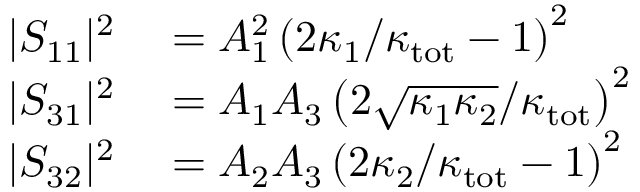Convert formula to latex. <formula><loc_0><loc_0><loc_500><loc_500>\begin{array} { r l } { | S _ { 1 1 } | ^ { 2 } } & = A _ { 1 } ^ { 2 } \left ( 2 \kappa _ { 1 } / \kappa _ { t o t } - 1 \right ) ^ { 2 } } \\ { | S _ { 3 1 } | ^ { 2 } } & = A _ { 1 } A _ { 3 } \left ( 2 \sqrt { \kappa _ { 1 } \kappa _ { 2 } } / \kappa _ { t o t } \right ) ^ { 2 } } \\ { | S _ { 3 2 } | ^ { 2 } } & = A _ { 2 } A _ { 3 } \left ( 2 \kappa _ { 2 } / \kappa _ { t o t } - 1 \right ) ^ { 2 } } \end{array}</formula> 